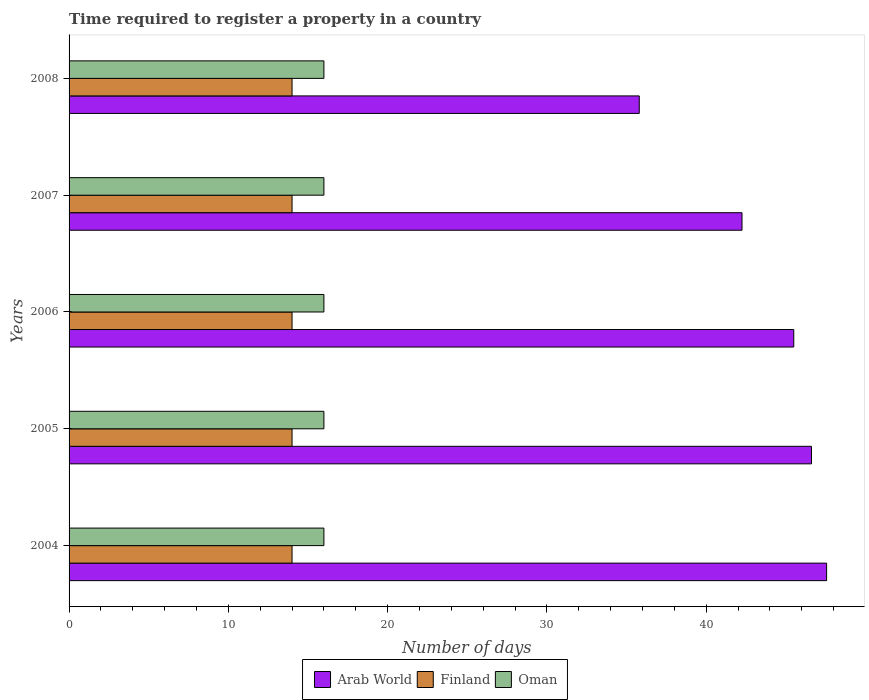How many groups of bars are there?
Make the answer very short. 5. How many bars are there on the 2nd tick from the bottom?
Ensure brevity in your answer.  3. What is the number of days required to register a property in Finland in 2005?
Ensure brevity in your answer.  14. Across all years, what is the maximum number of days required to register a property in Oman?
Give a very brief answer. 16. Across all years, what is the minimum number of days required to register a property in Arab World?
Keep it short and to the point. 35.8. In which year was the number of days required to register a property in Arab World minimum?
Offer a very short reply. 2008. What is the total number of days required to register a property in Oman in the graph?
Offer a terse response. 80. What is the difference between the number of days required to register a property in Arab World in 2005 and that in 2007?
Keep it short and to the point. 4.36. What is the difference between the number of days required to register a property in Finland in 2004 and the number of days required to register a property in Arab World in 2008?
Ensure brevity in your answer.  -21.8. What is the average number of days required to register a property in Arab World per year?
Provide a short and direct response. 43.54. In the year 2004, what is the difference between the number of days required to register a property in Finland and number of days required to register a property in Arab World?
Provide a short and direct response. -33.56. In how many years, is the number of days required to register a property in Arab World greater than 22 days?
Ensure brevity in your answer.  5. What is the ratio of the number of days required to register a property in Oman in 2005 to that in 2007?
Offer a terse response. 1. Is the number of days required to register a property in Arab World in 2004 less than that in 2007?
Provide a short and direct response. No. Is the difference between the number of days required to register a property in Finland in 2006 and 2007 greater than the difference between the number of days required to register a property in Arab World in 2006 and 2007?
Make the answer very short. No. What does the 3rd bar from the top in 2006 represents?
Offer a very short reply. Arab World. Is it the case that in every year, the sum of the number of days required to register a property in Oman and number of days required to register a property in Finland is greater than the number of days required to register a property in Arab World?
Your response must be concise. No. Are all the bars in the graph horizontal?
Make the answer very short. Yes. What is the difference between two consecutive major ticks on the X-axis?
Make the answer very short. 10. How are the legend labels stacked?
Your answer should be very brief. Horizontal. What is the title of the graph?
Make the answer very short. Time required to register a property in a country. Does "Mongolia" appear as one of the legend labels in the graph?
Your response must be concise. No. What is the label or title of the X-axis?
Your answer should be compact. Number of days. What is the label or title of the Y-axis?
Give a very brief answer. Years. What is the Number of days of Arab World in 2004?
Offer a terse response. 47.56. What is the Number of days in Arab World in 2005?
Your response must be concise. 46.61. What is the Number of days of Finland in 2005?
Offer a terse response. 14. What is the Number of days of Arab World in 2006?
Give a very brief answer. 45.5. What is the Number of days in Finland in 2006?
Offer a very short reply. 14. What is the Number of days of Oman in 2006?
Provide a succinct answer. 16. What is the Number of days in Arab World in 2007?
Provide a short and direct response. 42.25. What is the Number of days in Arab World in 2008?
Provide a succinct answer. 35.8. What is the Number of days of Finland in 2008?
Your response must be concise. 14. What is the Number of days in Oman in 2008?
Provide a short and direct response. 16. Across all years, what is the maximum Number of days of Arab World?
Give a very brief answer. 47.56. Across all years, what is the maximum Number of days in Finland?
Your response must be concise. 14. Across all years, what is the maximum Number of days in Oman?
Your answer should be compact. 16. Across all years, what is the minimum Number of days of Arab World?
Give a very brief answer. 35.8. Across all years, what is the minimum Number of days of Finland?
Ensure brevity in your answer.  14. What is the total Number of days of Arab World in the graph?
Offer a terse response. 217.72. What is the total Number of days in Oman in the graph?
Offer a terse response. 80. What is the difference between the Number of days in Arab World in 2004 and that in 2005?
Offer a terse response. 0.95. What is the difference between the Number of days of Finland in 2004 and that in 2005?
Offer a terse response. 0. What is the difference between the Number of days in Oman in 2004 and that in 2005?
Keep it short and to the point. 0. What is the difference between the Number of days of Arab World in 2004 and that in 2006?
Offer a very short reply. 2.06. What is the difference between the Number of days of Arab World in 2004 and that in 2007?
Offer a terse response. 5.31. What is the difference between the Number of days of Finland in 2004 and that in 2007?
Ensure brevity in your answer.  0. What is the difference between the Number of days in Arab World in 2004 and that in 2008?
Provide a succinct answer. 11.76. What is the difference between the Number of days of Arab World in 2005 and that in 2006?
Provide a short and direct response. 1.11. What is the difference between the Number of days in Finland in 2005 and that in 2006?
Make the answer very short. 0. What is the difference between the Number of days of Oman in 2005 and that in 2006?
Your answer should be compact. 0. What is the difference between the Number of days of Arab World in 2005 and that in 2007?
Your answer should be very brief. 4.36. What is the difference between the Number of days of Finland in 2005 and that in 2007?
Provide a succinct answer. 0. What is the difference between the Number of days in Arab World in 2005 and that in 2008?
Offer a very short reply. 10.81. What is the difference between the Number of days in Finland in 2005 and that in 2008?
Provide a succinct answer. 0. What is the difference between the Number of days of Finland in 2006 and that in 2007?
Keep it short and to the point. 0. What is the difference between the Number of days of Arab World in 2007 and that in 2008?
Keep it short and to the point. 6.45. What is the difference between the Number of days in Finland in 2007 and that in 2008?
Provide a succinct answer. 0. What is the difference between the Number of days in Arab World in 2004 and the Number of days in Finland in 2005?
Offer a very short reply. 33.56. What is the difference between the Number of days in Arab World in 2004 and the Number of days in Oman in 2005?
Your answer should be compact. 31.56. What is the difference between the Number of days in Finland in 2004 and the Number of days in Oman in 2005?
Make the answer very short. -2. What is the difference between the Number of days of Arab World in 2004 and the Number of days of Finland in 2006?
Make the answer very short. 33.56. What is the difference between the Number of days of Arab World in 2004 and the Number of days of Oman in 2006?
Your response must be concise. 31.56. What is the difference between the Number of days in Arab World in 2004 and the Number of days in Finland in 2007?
Give a very brief answer. 33.56. What is the difference between the Number of days of Arab World in 2004 and the Number of days of Oman in 2007?
Your response must be concise. 31.56. What is the difference between the Number of days in Finland in 2004 and the Number of days in Oman in 2007?
Ensure brevity in your answer.  -2. What is the difference between the Number of days of Arab World in 2004 and the Number of days of Finland in 2008?
Keep it short and to the point. 33.56. What is the difference between the Number of days of Arab World in 2004 and the Number of days of Oman in 2008?
Your answer should be compact. 31.56. What is the difference between the Number of days in Finland in 2004 and the Number of days in Oman in 2008?
Your response must be concise. -2. What is the difference between the Number of days in Arab World in 2005 and the Number of days in Finland in 2006?
Provide a succinct answer. 32.61. What is the difference between the Number of days of Arab World in 2005 and the Number of days of Oman in 2006?
Make the answer very short. 30.61. What is the difference between the Number of days of Arab World in 2005 and the Number of days of Finland in 2007?
Keep it short and to the point. 32.61. What is the difference between the Number of days of Arab World in 2005 and the Number of days of Oman in 2007?
Keep it short and to the point. 30.61. What is the difference between the Number of days of Arab World in 2005 and the Number of days of Finland in 2008?
Keep it short and to the point. 32.61. What is the difference between the Number of days in Arab World in 2005 and the Number of days in Oman in 2008?
Your answer should be compact. 30.61. What is the difference between the Number of days of Finland in 2005 and the Number of days of Oman in 2008?
Your answer should be very brief. -2. What is the difference between the Number of days of Arab World in 2006 and the Number of days of Finland in 2007?
Provide a succinct answer. 31.5. What is the difference between the Number of days in Arab World in 2006 and the Number of days in Oman in 2007?
Your answer should be compact. 29.5. What is the difference between the Number of days in Finland in 2006 and the Number of days in Oman in 2007?
Provide a succinct answer. -2. What is the difference between the Number of days in Arab World in 2006 and the Number of days in Finland in 2008?
Provide a succinct answer. 31.5. What is the difference between the Number of days of Arab World in 2006 and the Number of days of Oman in 2008?
Ensure brevity in your answer.  29.5. What is the difference between the Number of days in Finland in 2006 and the Number of days in Oman in 2008?
Offer a very short reply. -2. What is the difference between the Number of days of Arab World in 2007 and the Number of days of Finland in 2008?
Make the answer very short. 28.25. What is the difference between the Number of days of Arab World in 2007 and the Number of days of Oman in 2008?
Make the answer very short. 26.25. What is the average Number of days of Arab World per year?
Keep it short and to the point. 43.54. What is the average Number of days in Finland per year?
Offer a terse response. 14. What is the average Number of days in Oman per year?
Your answer should be very brief. 16. In the year 2004, what is the difference between the Number of days of Arab World and Number of days of Finland?
Make the answer very short. 33.56. In the year 2004, what is the difference between the Number of days in Arab World and Number of days in Oman?
Provide a short and direct response. 31.56. In the year 2005, what is the difference between the Number of days in Arab World and Number of days in Finland?
Keep it short and to the point. 32.61. In the year 2005, what is the difference between the Number of days of Arab World and Number of days of Oman?
Provide a succinct answer. 30.61. In the year 2005, what is the difference between the Number of days of Finland and Number of days of Oman?
Keep it short and to the point. -2. In the year 2006, what is the difference between the Number of days in Arab World and Number of days in Finland?
Keep it short and to the point. 31.5. In the year 2006, what is the difference between the Number of days of Arab World and Number of days of Oman?
Your answer should be compact. 29.5. In the year 2007, what is the difference between the Number of days in Arab World and Number of days in Finland?
Give a very brief answer. 28.25. In the year 2007, what is the difference between the Number of days in Arab World and Number of days in Oman?
Give a very brief answer. 26.25. In the year 2007, what is the difference between the Number of days of Finland and Number of days of Oman?
Offer a very short reply. -2. In the year 2008, what is the difference between the Number of days of Arab World and Number of days of Finland?
Make the answer very short. 21.8. In the year 2008, what is the difference between the Number of days in Arab World and Number of days in Oman?
Make the answer very short. 19.8. In the year 2008, what is the difference between the Number of days in Finland and Number of days in Oman?
Your answer should be compact. -2. What is the ratio of the Number of days of Arab World in 2004 to that in 2005?
Make the answer very short. 1.02. What is the ratio of the Number of days in Finland in 2004 to that in 2005?
Your answer should be compact. 1. What is the ratio of the Number of days of Arab World in 2004 to that in 2006?
Keep it short and to the point. 1.05. What is the ratio of the Number of days of Finland in 2004 to that in 2006?
Your answer should be very brief. 1. What is the ratio of the Number of days of Arab World in 2004 to that in 2007?
Provide a short and direct response. 1.13. What is the ratio of the Number of days in Arab World in 2004 to that in 2008?
Keep it short and to the point. 1.33. What is the ratio of the Number of days of Finland in 2004 to that in 2008?
Your answer should be compact. 1. What is the ratio of the Number of days of Oman in 2004 to that in 2008?
Your response must be concise. 1. What is the ratio of the Number of days of Arab World in 2005 to that in 2006?
Ensure brevity in your answer.  1.02. What is the ratio of the Number of days of Arab World in 2005 to that in 2007?
Your response must be concise. 1.1. What is the ratio of the Number of days in Arab World in 2005 to that in 2008?
Your response must be concise. 1.3. What is the ratio of the Number of days of Finland in 2005 to that in 2008?
Your answer should be very brief. 1. What is the ratio of the Number of days of Finland in 2006 to that in 2007?
Keep it short and to the point. 1. What is the ratio of the Number of days in Oman in 2006 to that in 2007?
Your answer should be compact. 1. What is the ratio of the Number of days in Arab World in 2006 to that in 2008?
Keep it short and to the point. 1.27. What is the ratio of the Number of days in Oman in 2006 to that in 2008?
Your response must be concise. 1. What is the ratio of the Number of days in Arab World in 2007 to that in 2008?
Provide a short and direct response. 1.18. What is the difference between the highest and the second highest Number of days in Arab World?
Keep it short and to the point. 0.95. What is the difference between the highest and the lowest Number of days in Arab World?
Keep it short and to the point. 11.76. What is the difference between the highest and the lowest Number of days of Finland?
Offer a very short reply. 0. 